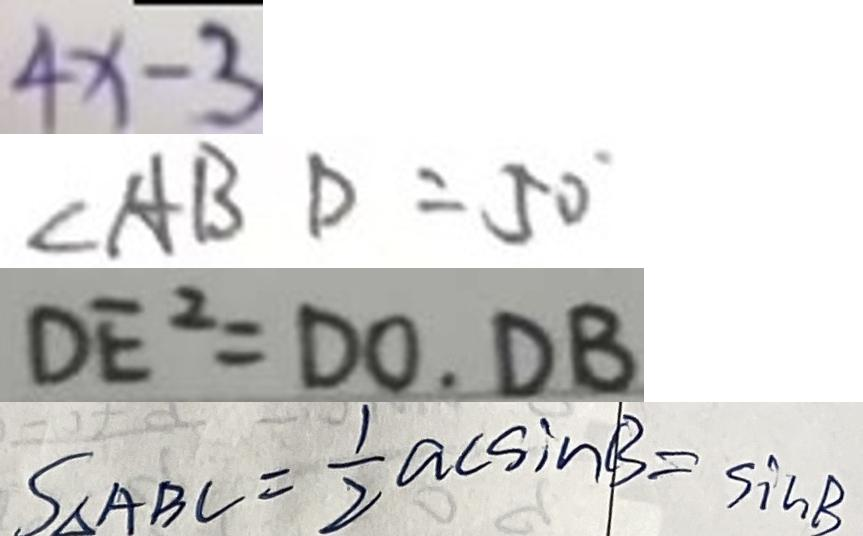<formula> <loc_0><loc_0><loc_500><loc_500>4 x - 3 
 \angle A B D = 5 0 ^ { \circ } 
 D E ^ { 2 } = D O . D B 
 S _ { \Delta A B C } = \frac { 1 } { 2 } a c \sin B = \sin B</formula> 